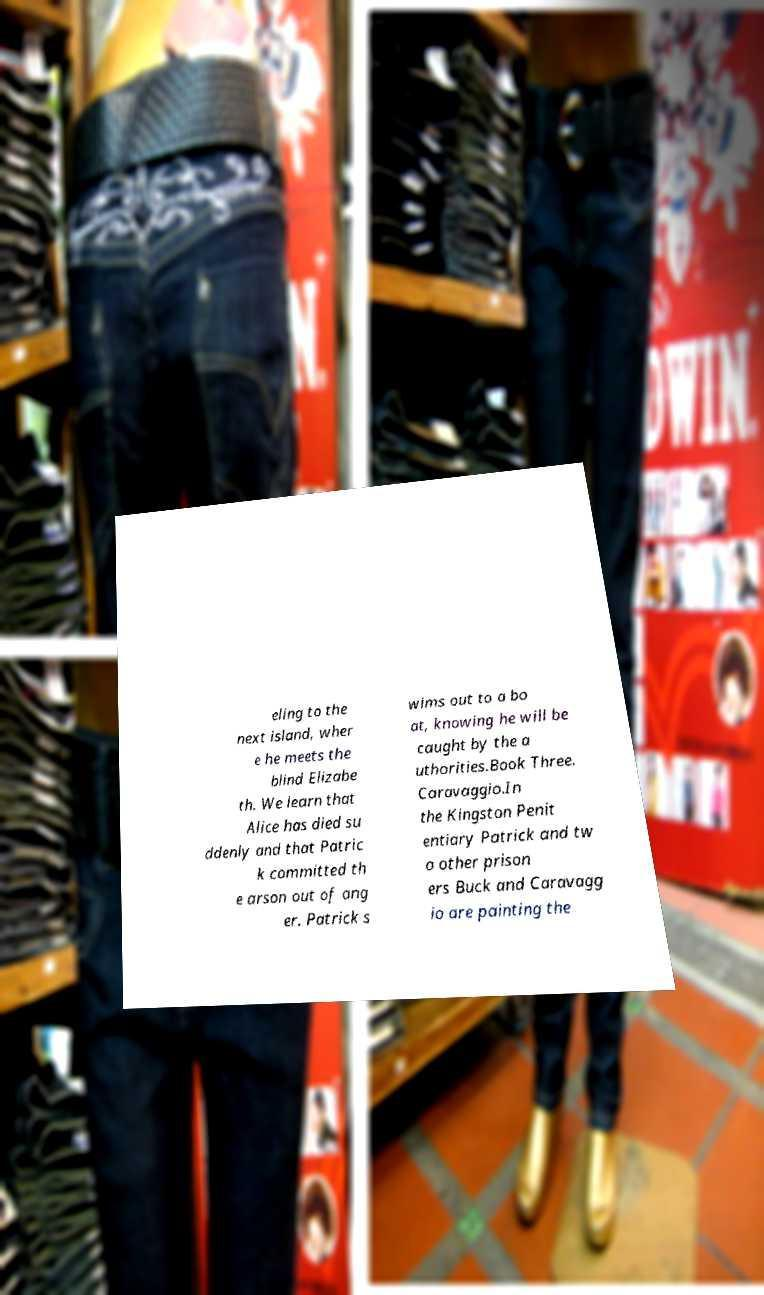Can you accurately transcribe the text from the provided image for me? eling to the next island, wher e he meets the blind Elizabe th. We learn that Alice has died su ddenly and that Patric k committed th e arson out of ang er. Patrick s wims out to a bo at, knowing he will be caught by the a uthorities.Book Three. Caravaggio.In the Kingston Penit entiary Patrick and tw o other prison ers Buck and Caravagg io are painting the 